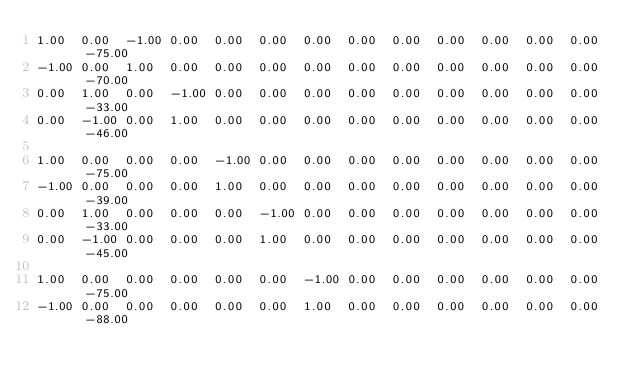<code> <loc_0><loc_0><loc_500><loc_500><_Matlab_>1.00	0.00	-1.00	0.00	0.00	0.00	0.00	0.00	0.00	0.00	0.00	0.00	0.00	-75.00
-1.00	0.00	1.00	0.00	0.00	0.00	0.00	0.00	0.00	0.00	0.00	0.00	0.00	-70.00
0.00	1.00	0.00	-1.00	0.00	0.00	0.00	0.00	0.00	0.00	0.00	0.00	0.00	-33.00
0.00	-1.00	0.00	1.00	0.00	0.00	0.00	0.00	0.00	0.00	0.00	0.00	0.00	-46.00

1.00	0.00	0.00	0.00	-1.00	0.00	0.00	0.00	0.00	0.00	0.00	0.00	0.00	-75.00
-1.00	0.00	0.00	0.00	1.00	0.00	0.00	0.00	0.00	0.00	0.00	0.00	0.00	-39.00
0.00	1.00	0.00	0.00	0.00	-1.00	0.00	0.00	0.00	0.00	0.00	0.00	0.00	-33.00
0.00	-1.00	0.00	0.00	0.00	1.00	0.00	0.00	0.00	0.00	0.00	0.00	0.00	-45.00

1.00	0.00	0.00	0.00	0.00	0.00	-1.00	0.00	0.00	0.00	0.00	0.00	0.00	-75.00
-1.00	0.00	0.00	0.00	0.00	0.00	1.00	0.00	0.00	0.00	0.00	0.00	0.00	-88.00</code> 